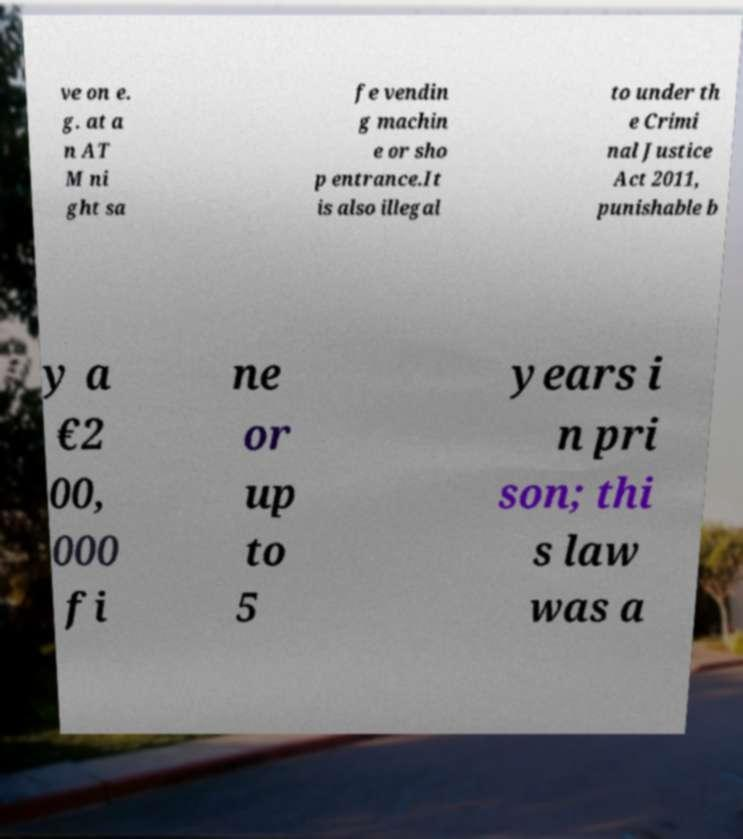Please read and relay the text visible in this image. What does it say? ve on e. g. at a n AT M ni ght sa fe vendin g machin e or sho p entrance.It is also illegal to under th e Crimi nal Justice Act 2011, punishable b y a €2 00, 000 fi ne or up to 5 years i n pri son; thi s law was a 